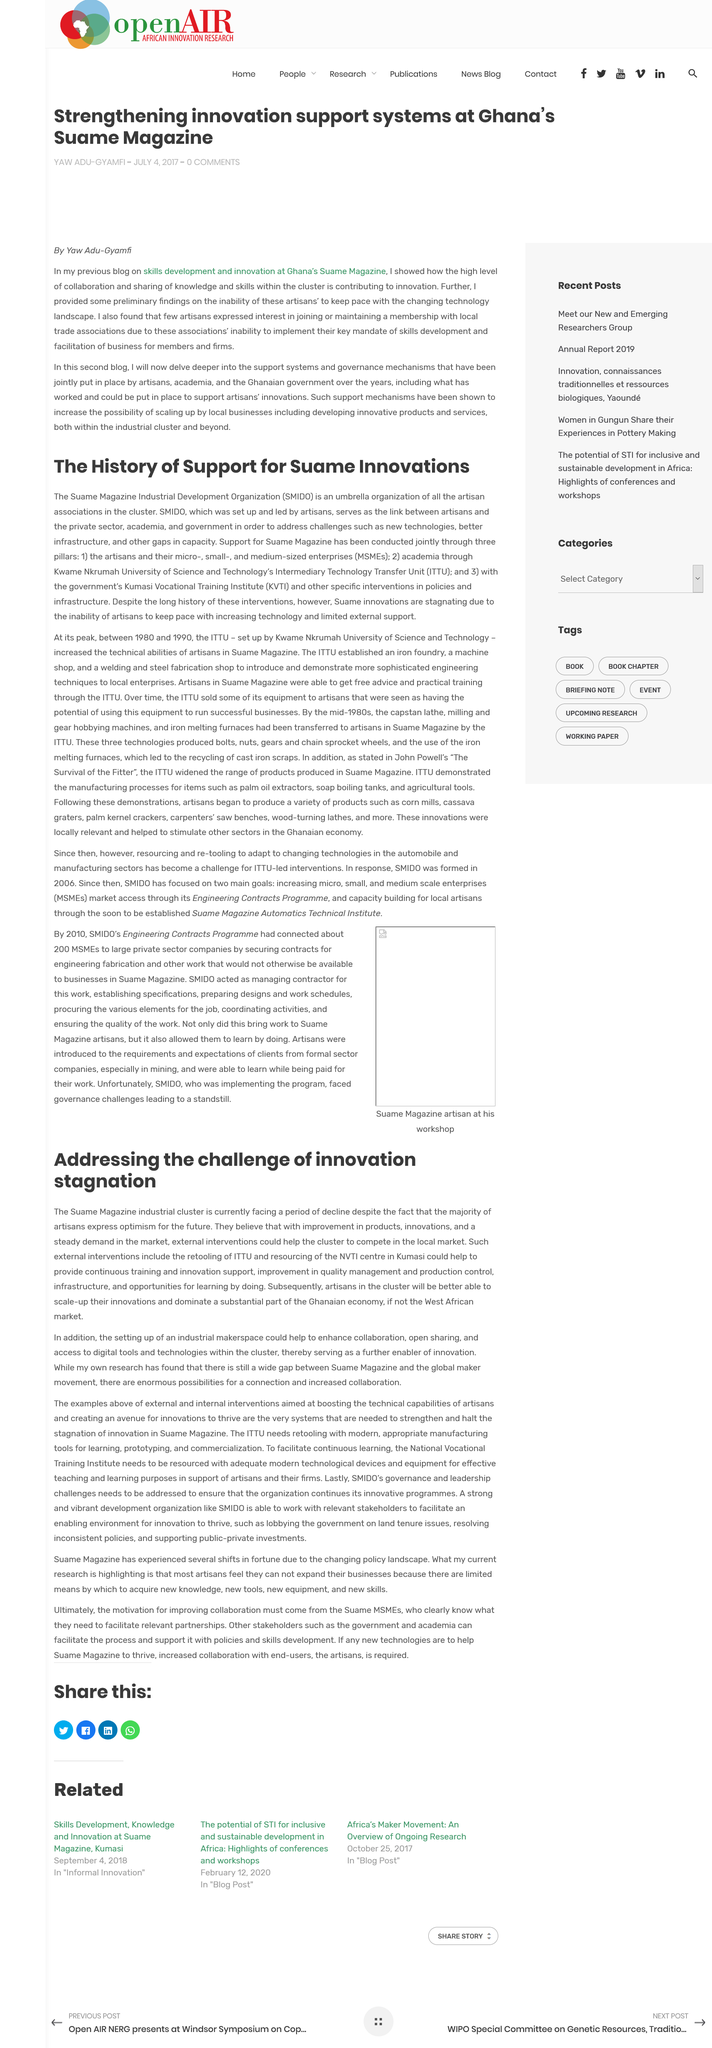List a handful of essential elements in this visual. Suame Magazine Industrial Development Organization (SMIDO) is an acronym that stands for a organization focused on promoting industrial development in the Suame Magazine area. This article is about innovation and what it encompasses. Under the heading 'The History of Support for Same Innovations,' the acronym KVTI refers to the Kumasi Vocational Training Institute. Artisans in the cluster will be better able to scale-up their innovations, yes, they will. The stagnation of Suame innovations can be attributed to the inability of artisans to keep up with advancing technology, as well as the lack of external support. 